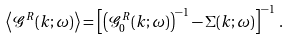Convert formula to latex. <formula><loc_0><loc_0><loc_500><loc_500>\left \langle \mathcal { G } ^ { R } ( k ; \omega ) \right \rangle = \left [ \left ( \mathcal { G } _ { 0 } ^ { R } ( k ; \omega ) \right ) ^ { - 1 } - \Sigma ( k ; \omega ) \right ] ^ { - 1 } \, .</formula> 